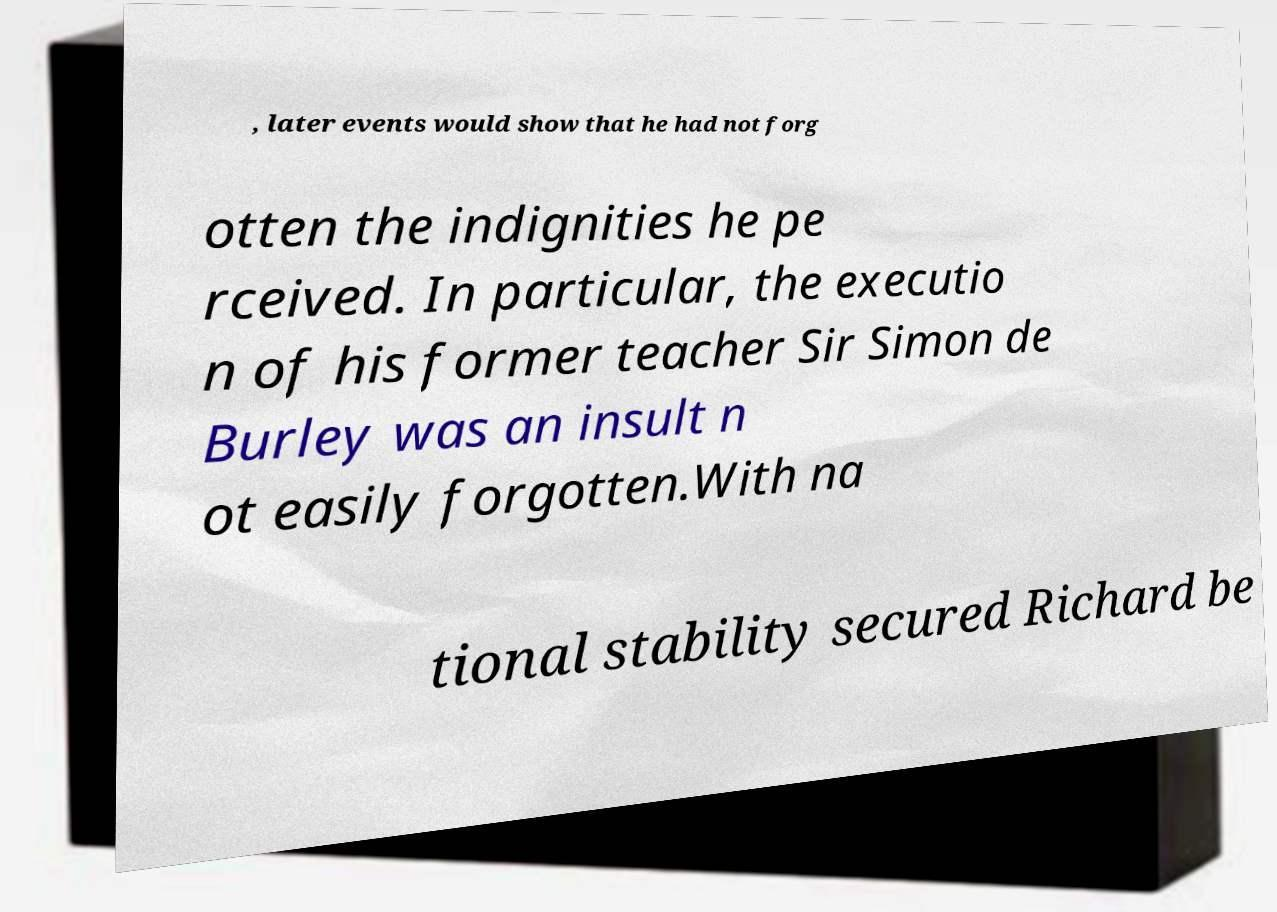There's text embedded in this image that I need extracted. Can you transcribe it verbatim? , later events would show that he had not forg otten the indignities he pe rceived. In particular, the executio n of his former teacher Sir Simon de Burley was an insult n ot easily forgotten.With na tional stability secured Richard be 